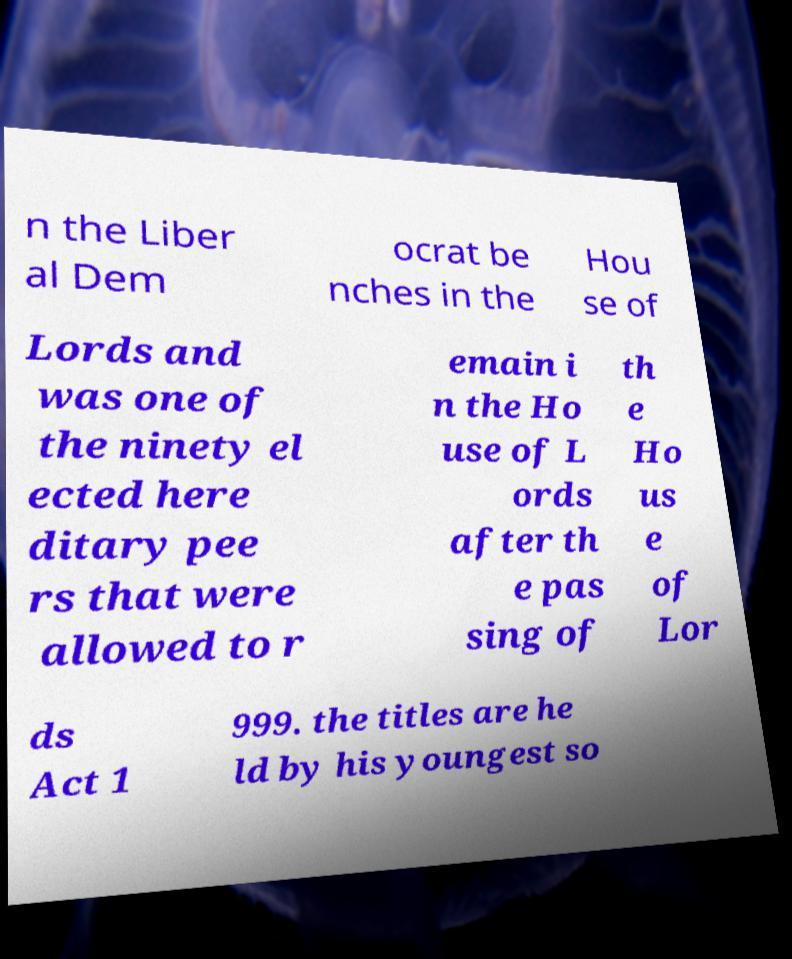For documentation purposes, I need the text within this image transcribed. Could you provide that? n the Liber al Dem ocrat be nches in the Hou se of Lords and was one of the ninety el ected here ditary pee rs that were allowed to r emain i n the Ho use of L ords after th e pas sing of th e Ho us e of Lor ds Act 1 999. the titles are he ld by his youngest so 